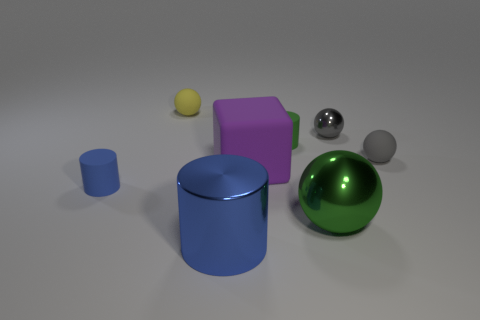There is a tiny matte cylinder in front of the small gray matte object; is it the same color as the rubber cube? No, the tiny matte cylinder in front of the small gray object is blue, whereas the rubber cube is purple. Despite both objects having matte finishes, their colors are distinctly different. 